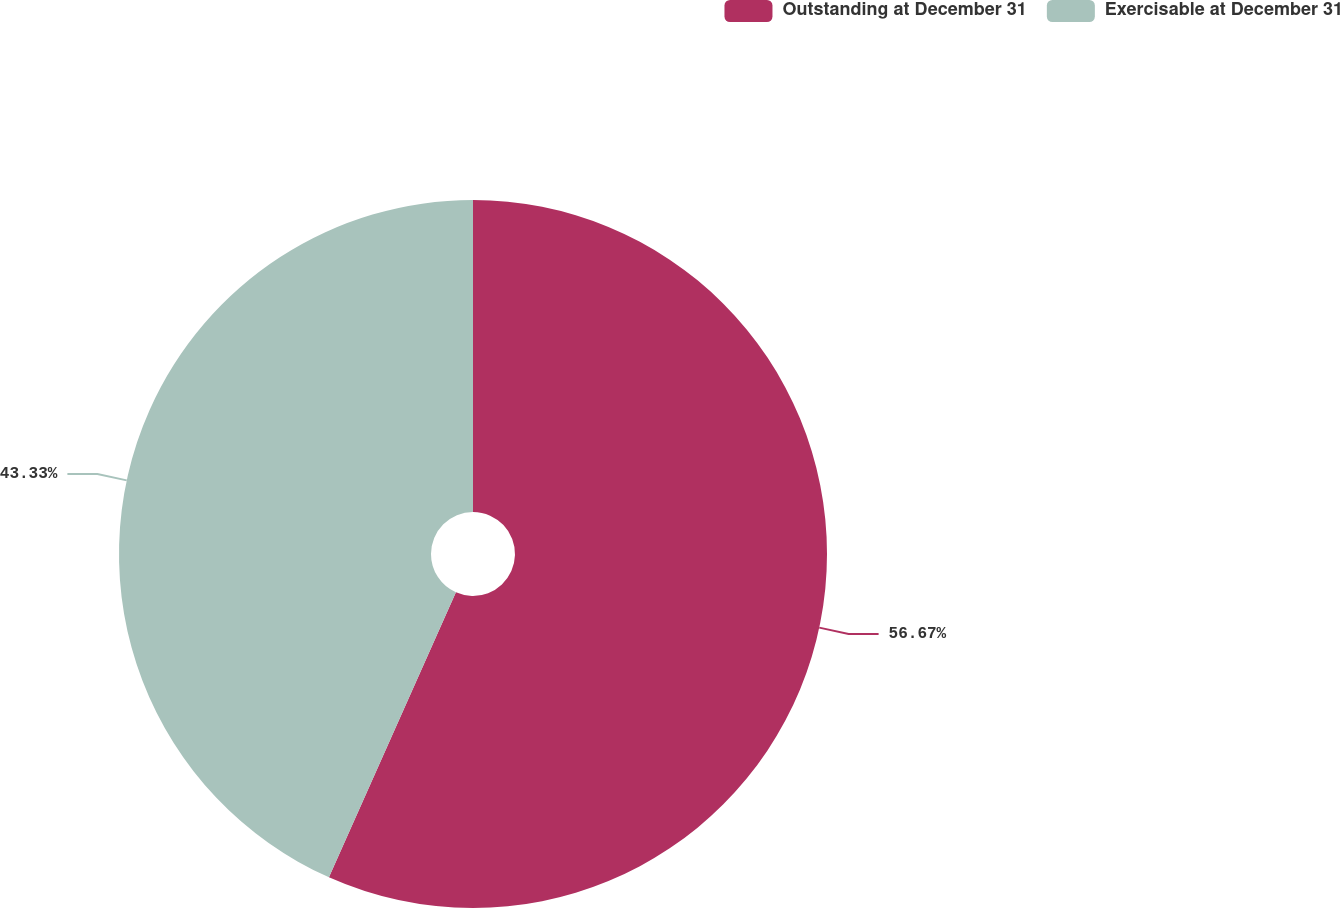Convert chart to OTSL. <chart><loc_0><loc_0><loc_500><loc_500><pie_chart><fcel>Outstanding at December 31<fcel>Exercisable at December 31<nl><fcel>56.67%<fcel>43.33%<nl></chart> 